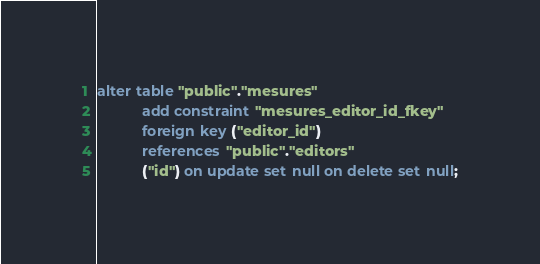<code> <loc_0><loc_0><loc_500><loc_500><_SQL_>alter table "public"."mesures"
           add constraint "mesures_editor_id_fkey"
           foreign key ("editor_id")
           references "public"."editors"
           ("id") on update set null on delete set null;
</code> 